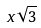<formula> <loc_0><loc_0><loc_500><loc_500>x \sqrt { 3 }</formula> 